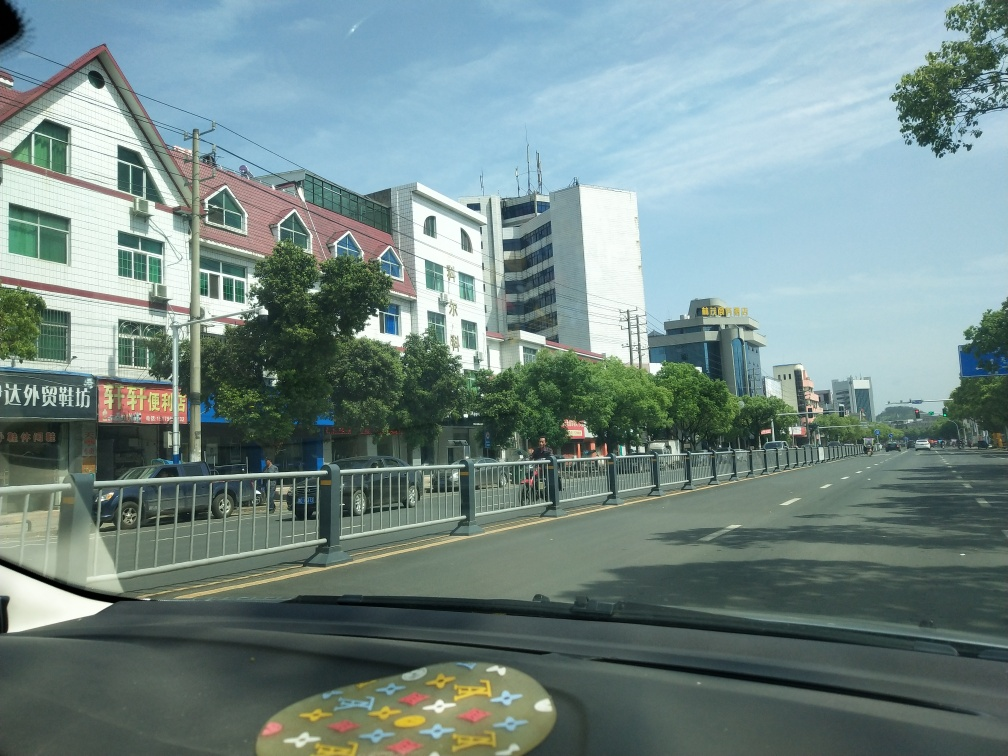Can you describe the setting captured in this image? Certainly! The image depicts an urban street scene during a clear day with blue skies. Multiple buildings with a variety of architectural styles line the road, indicating a mixed-use area with both commercial and possibly residential spaces. Many of the facades feature signage, suggesting the presence of businesses. A median with metal barriers runs down the center of a multi-lane roadway, and the absence of traffic hints at a possible non-peak hour or a less busy part of town. There's also an inconspicuous detail—an ornament with colorful fish designs placed on the dashboard, possibly inside the vehicle from where the photo was taken, adding a personal touch to the image. 